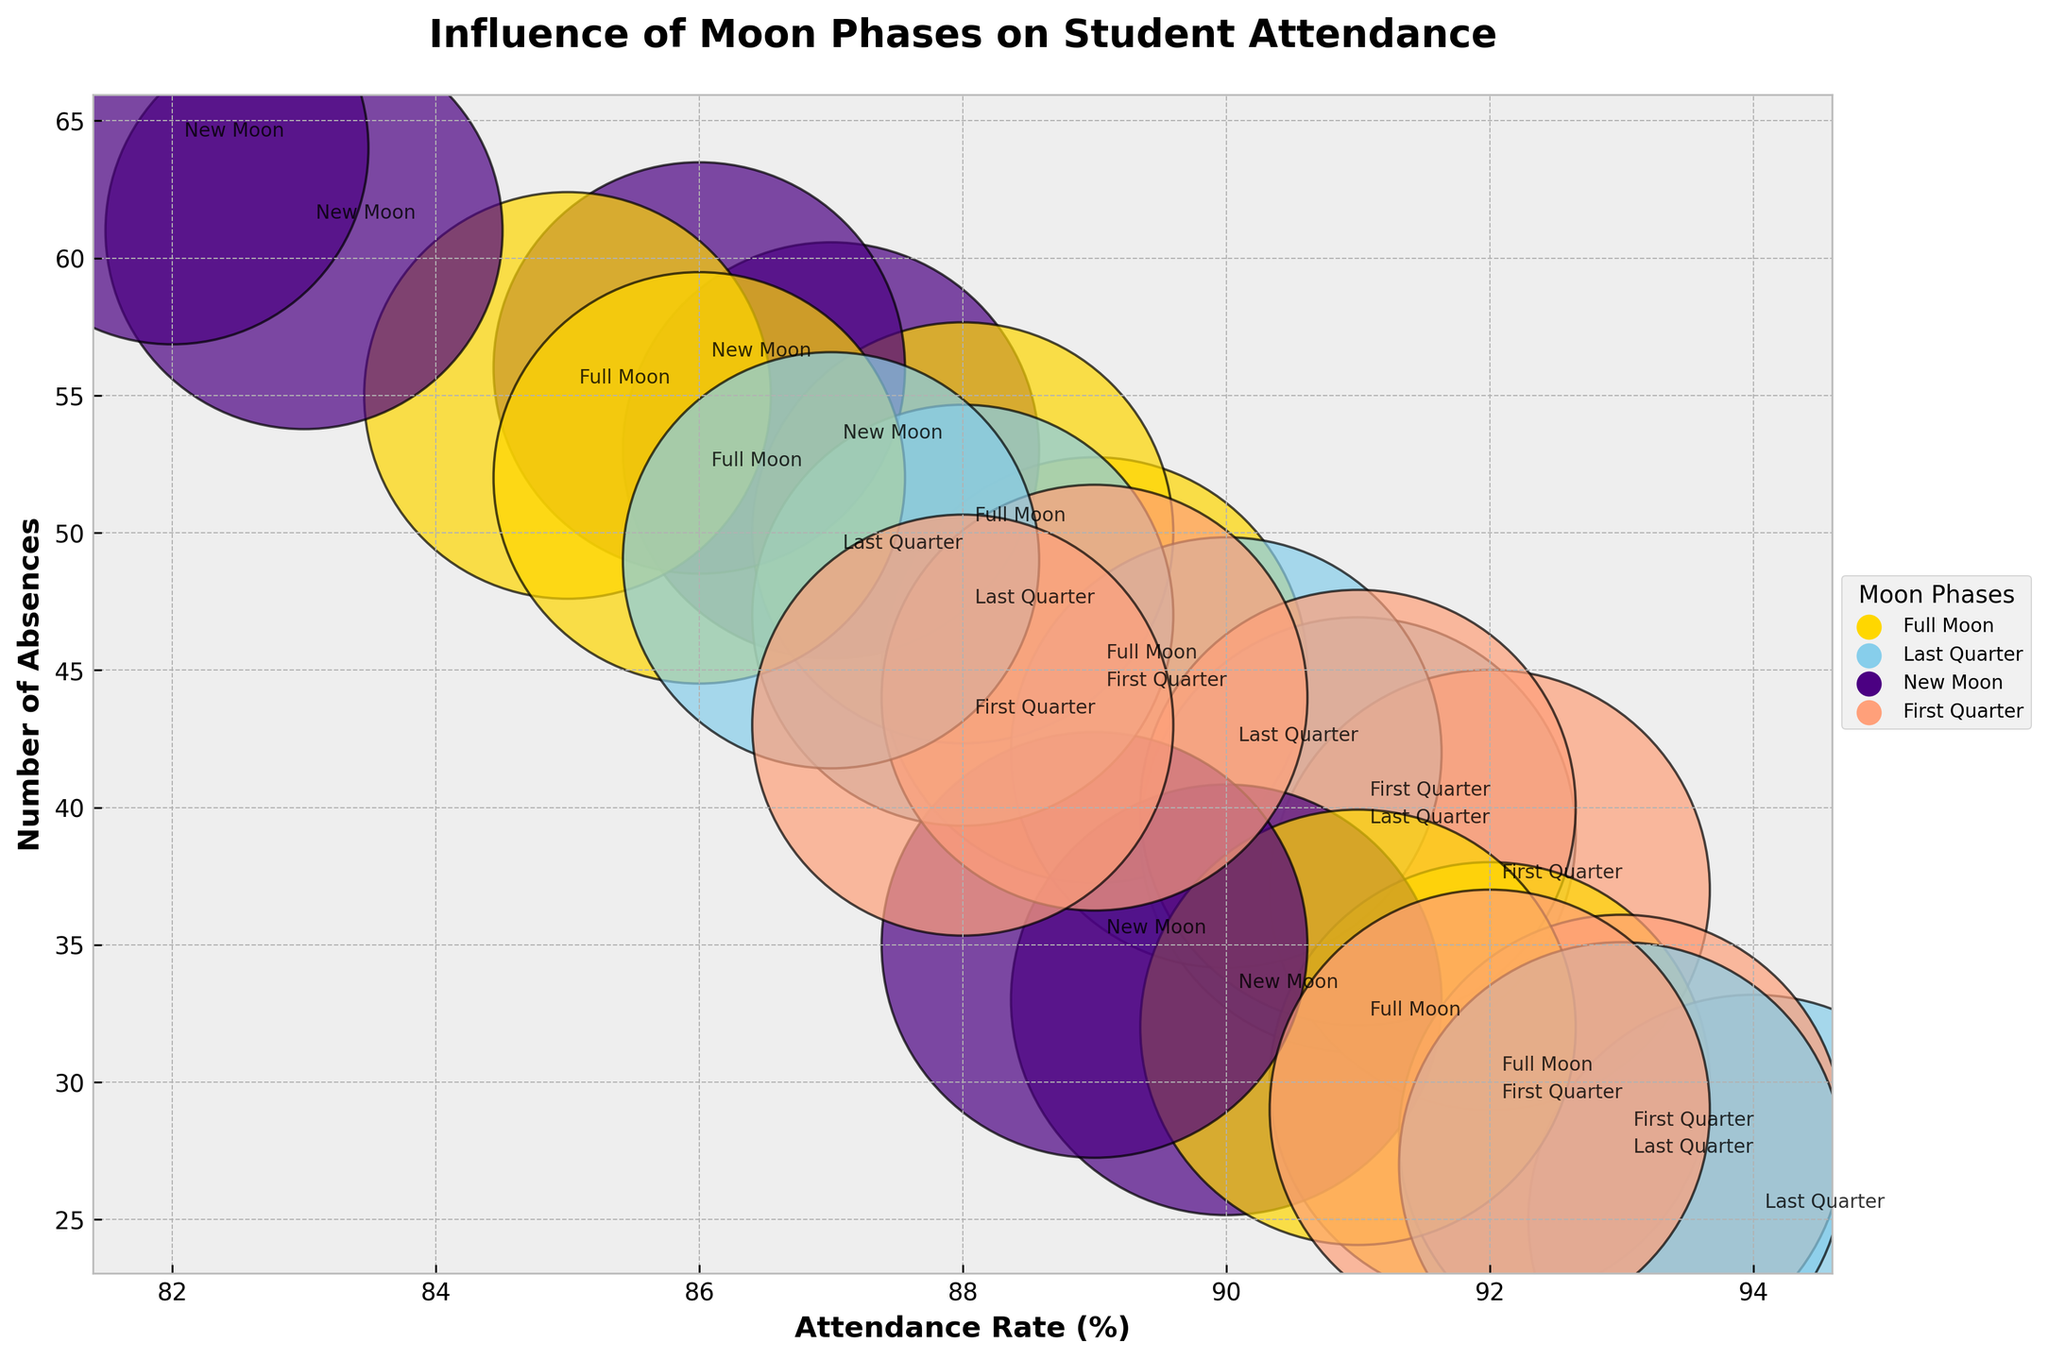What's the title of the plot? The title is written at the top of the plot. It describes the main focus of the chart.
Answer: Influence of Moon Phases on Student Attendance What do the x and y axes represent? The labels on the x and y axes tell us what they measure. The x-axis measures percentage of attendance rate, and the y-axis measures number of absences.
Answer: Attendance Rate (%) and Number of Absences What moon phase is represented by the color yellow? By referencing the legend associated with the colors of the moon phases, yellow represents the Full Moon phase.
Answer: Full Moon Which school has the highest attendance rate during the Last Quarter moon phase? Look for the points marked with the Last Quarter moon phase (presumably in blue) and compare their x-values (attendance rates). The highest x-value point corresponding to the Last Quarter will give the answer.
Answer: Hilltop Elementary Which moon phase generally shows the highest number of absences across all schools? Compare the y-values (number of absences) for each moon phase color in the plot. The color associated with the highest overall y-values indicates the moon phase with generally the highest absences.
Answer: New Moon What is the range of attendance rates for Greenwood High across all moon phases? Locate all points corresponding to Greenwood High and note their x-values (attendance rates). The range is the difference between the maximum and minimum x-values observed.
Answer: 86% to 92% How do the number of absences compare between Riverdale Secondary during Full Moon and New Moon phases? Locate the data points for Riverdale Secondary corresponding to Full Moon and New Moon phases. Compare their y-values (number of absences) directly. Full Moon is generally shown in yellow, and New Moon in dark blue.
Answer: Higher during New Moon (64 vs. 55 and 61 vs. 52) On which date was the attendance rate the lowest for Hilltop Elementary? Find the data points corresponding to Hilltop Elementary, then observe the x-values (attendance rate) to identify the minimum. Reference the moon phase annotation for the specific dates.
Answer: February 15 (89%) Is there a noticeable trend in the attendance rate for Riverdale Secondary during different moon phases? Observe the placement of Riverdale Secondary's points across different colored phases in the x-axis (attendance rate). A trend would show a consistent rise or fall pattern.
Answer: Tends to be lower during New Moon Which school has the smallest variance in attendance rates across different moon phases? Assess the spread of data points in the x-axis (attendance rate) for each school. The school with data points closest together has the smallest variance.
Answer: Hilltop Elementary 